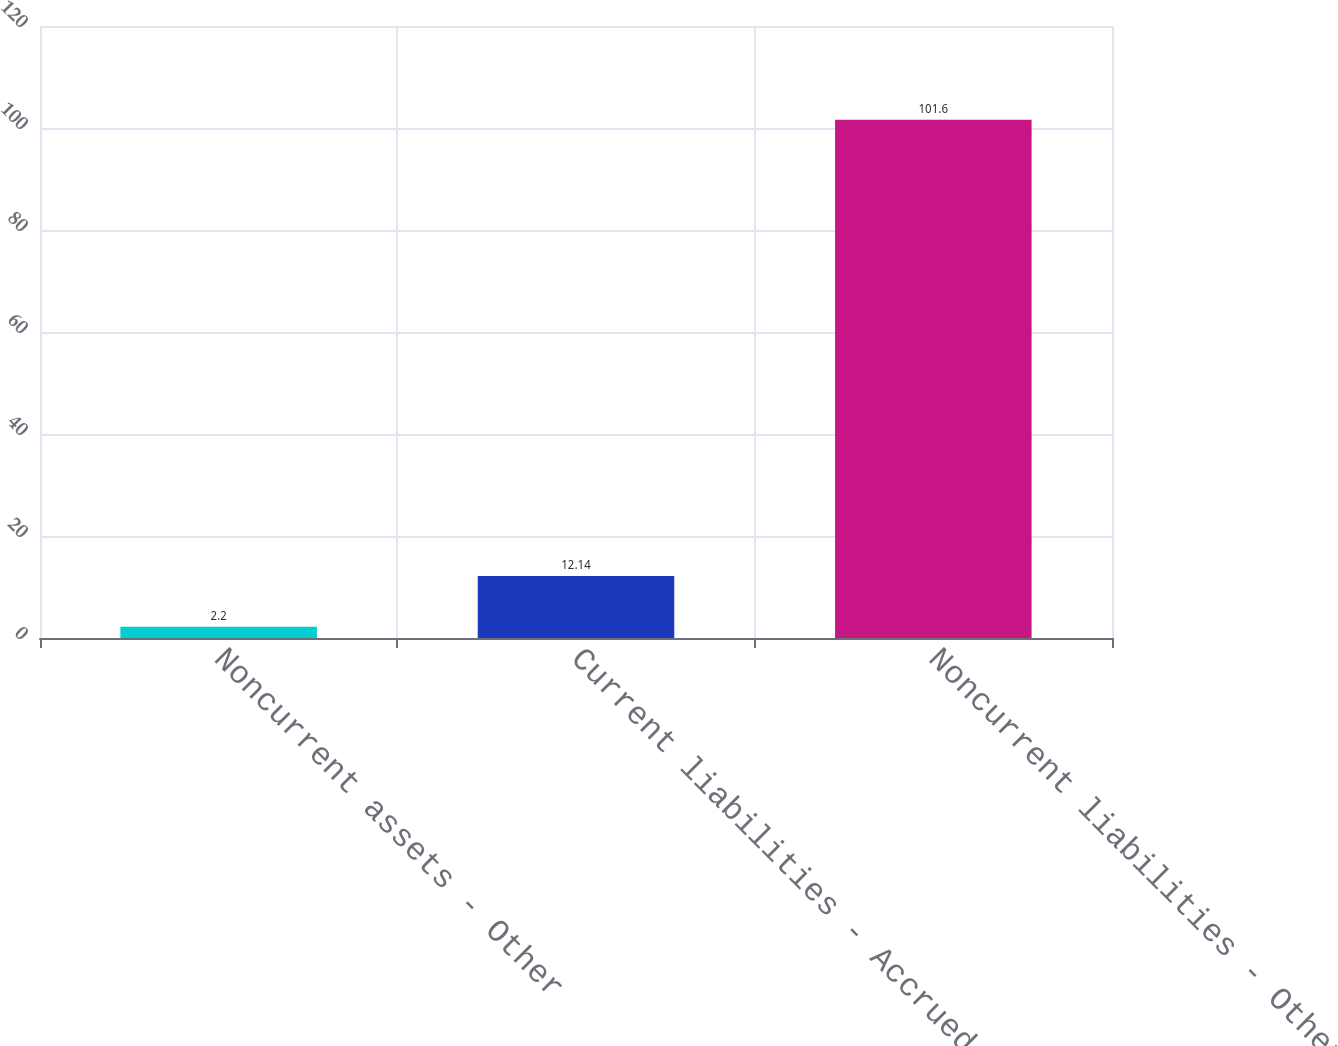Convert chart to OTSL. <chart><loc_0><loc_0><loc_500><loc_500><bar_chart><fcel>Noncurrent assets - Other<fcel>Current liabilities - Accrued<fcel>Noncurrent liabilities - Other<nl><fcel>2.2<fcel>12.14<fcel>101.6<nl></chart> 